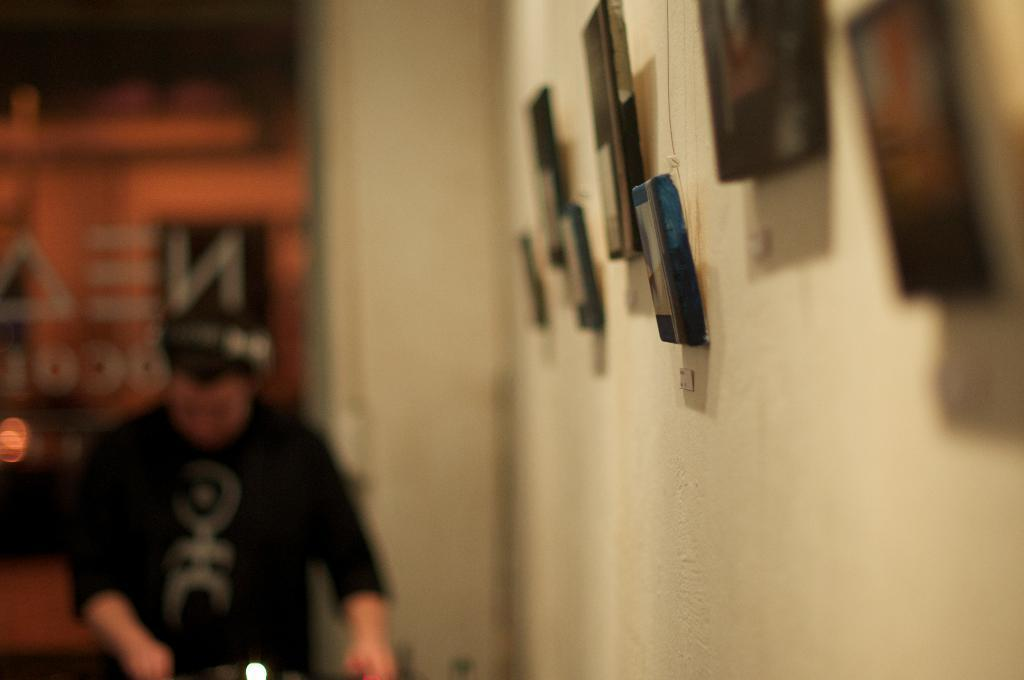What is attached to the wall in the image? There are objects attached to the wall in the image, but we cannot determine their specific nature from the provided facts. What is on the ground in the image? There are objects on the ground in the image, but we cannot determine their specific nature from the provided facts. What can be seen in the background of the image? There is text visible in the background of the image. What is the person in the image doing? The person is walking in the image and holding objects. How is the image quality? The image is blurred. What type of leather is visible on the person's sister in the image? There is no mention of leather, a person's sister, or any other person besides the one walking in the image. 